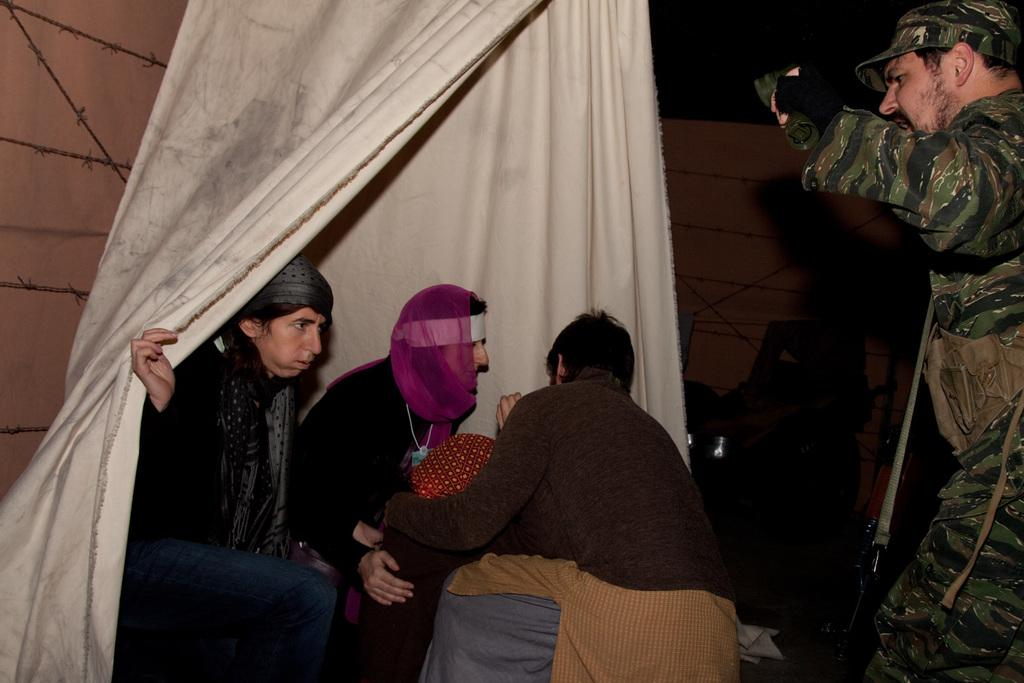What are the people in the image doing? The people in the image are sitting and standing. Can you describe the actions of the person holding a cloth? One person is holding a cloth. What can be seen on the head of the person standing? The person standing is wearing a cap. Where is the shelf located in the image? There is no shelf present in the image. What type of flight is the person wearing a cap taking in the image? There is no flight or travel-related information in the image; it only shows people sitting, standing, and holding a cloth. 